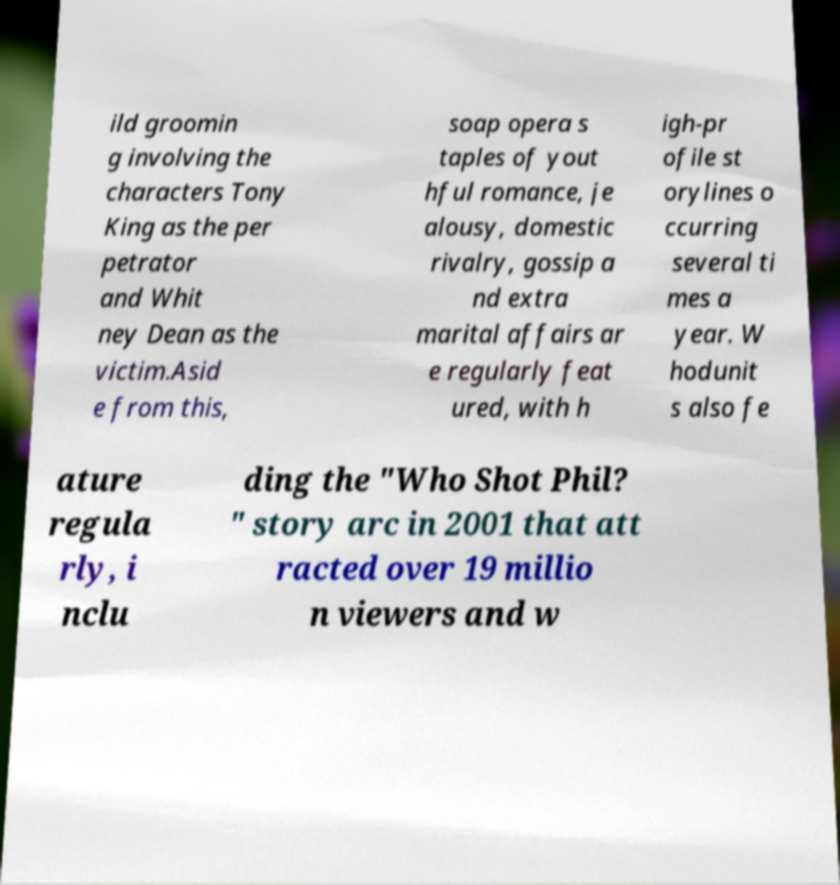Please identify and transcribe the text found in this image. ild groomin g involving the characters Tony King as the per petrator and Whit ney Dean as the victim.Asid e from this, soap opera s taples of yout hful romance, je alousy, domestic rivalry, gossip a nd extra marital affairs ar e regularly feat ured, with h igh-pr ofile st orylines o ccurring several ti mes a year. W hodunit s also fe ature regula rly, i nclu ding the "Who Shot Phil? " story arc in 2001 that att racted over 19 millio n viewers and w 